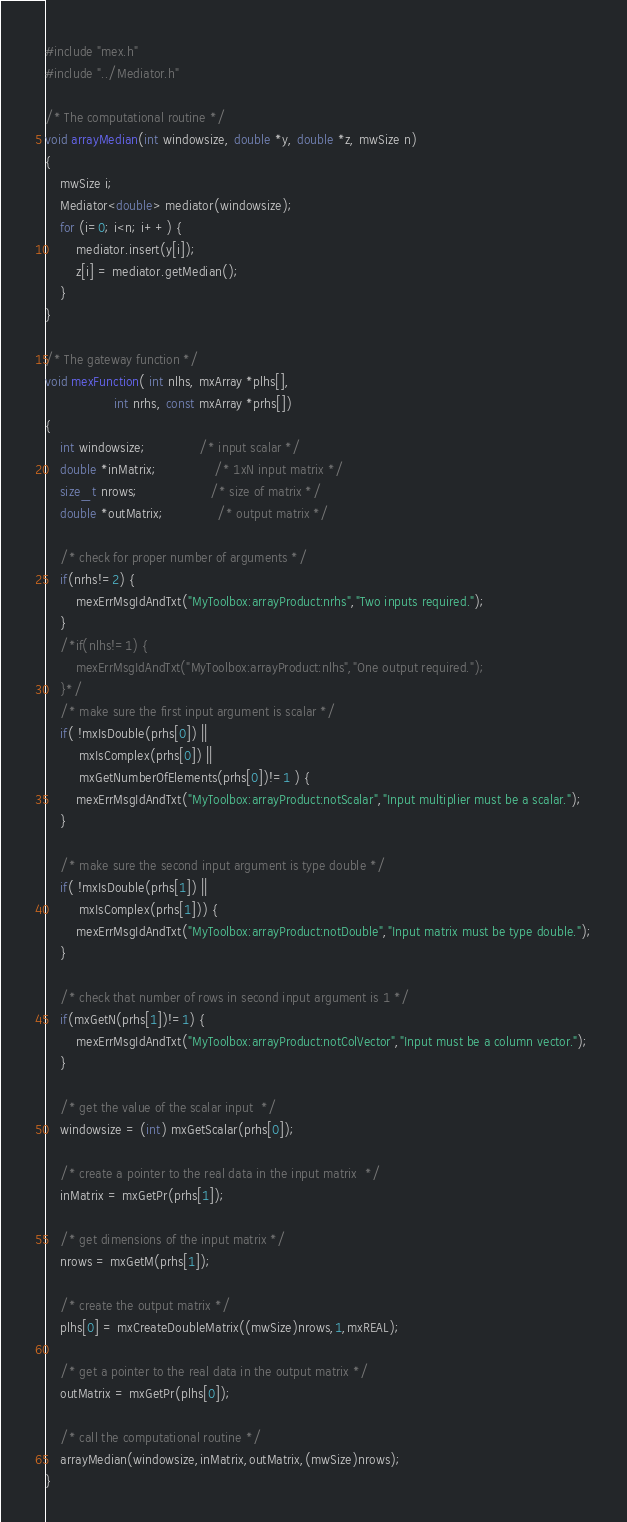Convert code to text. <code><loc_0><loc_0><loc_500><loc_500><_C++_>#include "mex.h"
#include "../Mediator.h"

/* The computational routine */
void arrayMedian(int windowsize, double *y, double *z, mwSize n)
{
    mwSize i;
    Mediator<double> mediator(windowsize);
    for (i=0; i<n; i++) {
        mediator.insert(y[i]);
        z[i] = mediator.getMedian();
    }
}

/* The gateway function */
void mexFunction( int nlhs, mxArray *plhs[],
                  int nrhs, const mxArray *prhs[])
{
    int windowsize;              /* input scalar */
    double *inMatrix;               /* 1xN input matrix */
    size_t nrows;                   /* size of matrix */
    double *outMatrix;              /* output matrix */

    /* check for proper number of arguments */
    if(nrhs!=2) {
        mexErrMsgIdAndTxt("MyToolbox:arrayProduct:nrhs","Two inputs required.");
    }
    /*if(nlhs!=1) {
        mexErrMsgIdAndTxt("MyToolbox:arrayProduct:nlhs","One output required.");
    }*/
    /* make sure the first input argument is scalar */
    if( !mxIsDouble(prhs[0]) || 
         mxIsComplex(prhs[0]) ||
         mxGetNumberOfElements(prhs[0])!=1 ) {
        mexErrMsgIdAndTxt("MyToolbox:arrayProduct:notScalar","Input multiplier must be a scalar.");
    }
    
    /* make sure the second input argument is type double */
    if( !mxIsDouble(prhs[1]) || 
         mxIsComplex(prhs[1])) {
        mexErrMsgIdAndTxt("MyToolbox:arrayProduct:notDouble","Input matrix must be type double.");
    }
    
    /* check that number of rows in second input argument is 1 */
    if(mxGetN(prhs[1])!=1) {
        mexErrMsgIdAndTxt("MyToolbox:arrayProduct:notColVector","Input must be a column vector.");
    }
    
    /* get the value of the scalar input  */
    windowsize = (int) mxGetScalar(prhs[0]);

    /* create a pointer to the real data in the input matrix  */
    inMatrix = mxGetPr(prhs[1]);

    /* get dimensions of the input matrix */
    nrows = mxGetM(prhs[1]);

    /* create the output matrix */
    plhs[0] = mxCreateDoubleMatrix((mwSize)nrows,1,mxREAL);

    /* get a pointer to the real data in the output matrix */
    outMatrix = mxGetPr(plhs[0]);

    /* call the computational routine */
    arrayMedian(windowsize,inMatrix,outMatrix,(mwSize)nrows);
}
</code> 